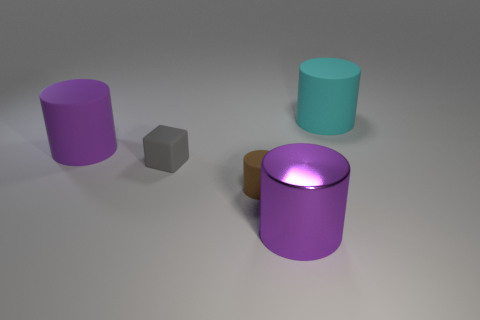What materials might the objects be made of based on their appearance? Based on their appearance, the objects seem to have different material qualities. The tiny gray object looks like it could be made of a matte material such as stone or unpolished metal, due to its non-reflective surface. The cylindrical objects might be made of a plastic or metal with a glossy finish, which is suggested by their reflective and smooth surfaces. 